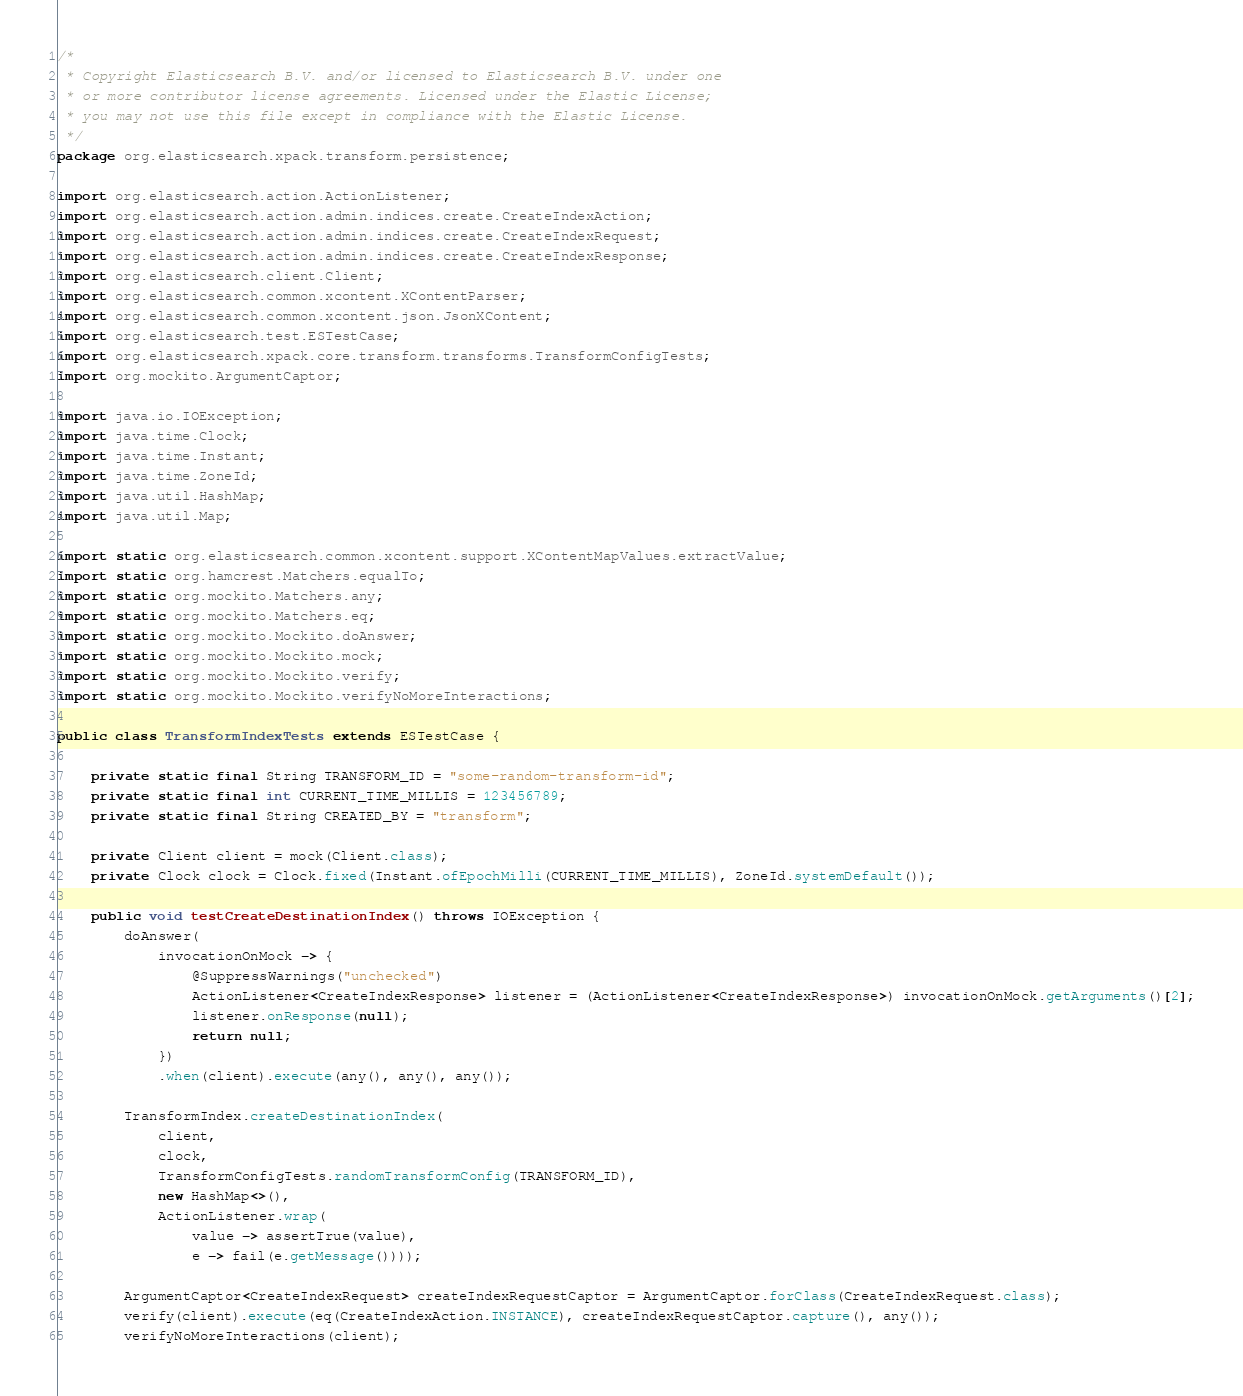Convert code to text. <code><loc_0><loc_0><loc_500><loc_500><_Java_>/*
 * Copyright Elasticsearch B.V. and/or licensed to Elasticsearch B.V. under one
 * or more contributor license agreements. Licensed under the Elastic License;
 * you may not use this file except in compliance with the Elastic License.
 */
package org.elasticsearch.xpack.transform.persistence;

import org.elasticsearch.action.ActionListener;
import org.elasticsearch.action.admin.indices.create.CreateIndexAction;
import org.elasticsearch.action.admin.indices.create.CreateIndexRequest;
import org.elasticsearch.action.admin.indices.create.CreateIndexResponse;
import org.elasticsearch.client.Client;
import org.elasticsearch.common.xcontent.XContentParser;
import org.elasticsearch.common.xcontent.json.JsonXContent;
import org.elasticsearch.test.ESTestCase;
import org.elasticsearch.xpack.core.transform.transforms.TransformConfigTests;
import org.mockito.ArgumentCaptor;

import java.io.IOException;
import java.time.Clock;
import java.time.Instant;
import java.time.ZoneId;
import java.util.HashMap;
import java.util.Map;

import static org.elasticsearch.common.xcontent.support.XContentMapValues.extractValue;
import static org.hamcrest.Matchers.equalTo;
import static org.mockito.Matchers.any;
import static org.mockito.Matchers.eq;
import static org.mockito.Mockito.doAnswer;
import static org.mockito.Mockito.mock;
import static org.mockito.Mockito.verify;
import static org.mockito.Mockito.verifyNoMoreInteractions;

public class TransformIndexTests extends ESTestCase {

    private static final String TRANSFORM_ID = "some-random-transform-id";
    private static final int CURRENT_TIME_MILLIS = 123456789;
    private static final String CREATED_BY = "transform";

    private Client client = mock(Client.class);
    private Clock clock = Clock.fixed(Instant.ofEpochMilli(CURRENT_TIME_MILLIS), ZoneId.systemDefault());

    public void testCreateDestinationIndex() throws IOException {
        doAnswer(
            invocationOnMock -> {
                @SuppressWarnings("unchecked")
                ActionListener<CreateIndexResponse> listener = (ActionListener<CreateIndexResponse>) invocationOnMock.getArguments()[2];
                listener.onResponse(null);
                return null;
            })
            .when(client).execute(any(), any(), any());

        TransformIndex.createDestinationIndex(
            client,
            clock,
            TransformConfigTests.randomTransformConfig(TRANSFORM_ID),
            new HashMap<>(),
            ActionListener.wrap(
                value -> assertTrue(value),
                e -> fail(e.getMessage())));

        ArgumentCaptor<CreateIndexRequest> createIndexRequestCaptor = ArgumentCaptor.forClass(CreateIndexRequest.class);
        verify(client).execute(eq(CreateIndexAction.INSTANCE), createIndexRequestCaptor.capture(), any());
        verifyNoMoreInteractions(client);
</code> 